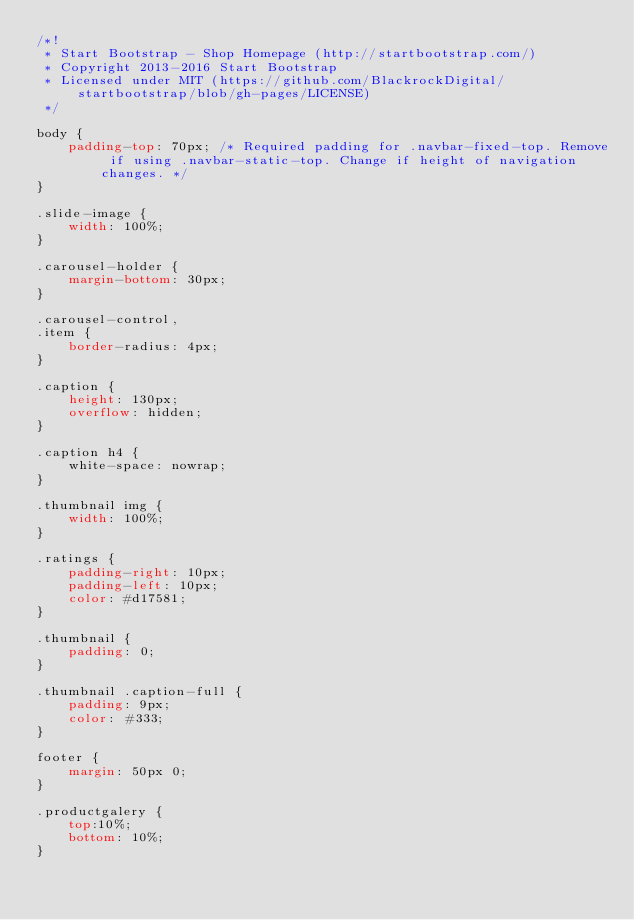Convert code to text. <code><loc_0><loc_0><loc_500><loc_500><_CSS_>/*!
 * Start Bootstrap - Shop Homepage (http://startbootstrap.com/)
 * Copyright 2013-2016 Start Bootstrap
 * Licensed under MIT (https://github.com/BlackrockDigital/startbootstrap/blob/gh-pages/LICENSE)
 */

body {
    padding-top: 70px; /* Required padding for .navbar-fixed-top. Remove if using .navbar-static-top. Change if height of navigation changes. */
}

.slide-image {
    width: 100%;
}

.carousel-holder {
    margin-bottom: 30px;
}

.carousel-control,
.item {
    border-radius: 4px;
}

.caption {
    height: 130px;
    overflow: hidden;
}

.caption h4 {
    white-space: nowrap;
}

.thumbnail img {
    width: 100%;
}

.ratings {
    padding-right: 10px;
    padding-left: 10px;
    color: #d17581;
}

.thumbnail {
    padding: 0;
}

.thumbnail .caption-full {
    padding: 9px;
    color: #333;
}

footer {
    margin: 50px 0;
}

.productgalery {
    top:10%;
    bottom: 10%;
}</code> 